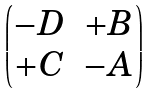Convert formula to latex. <formula><loc_0><loc_0><loc_500><loc_500>\begin{pmatrix} - D & + B \\ + C & - A \end{pmatrix}</formula> 